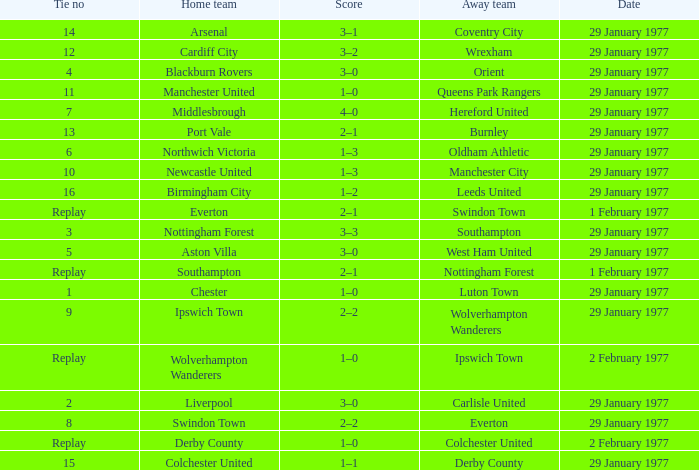Which away team has a tie number of 3? Southampton. 